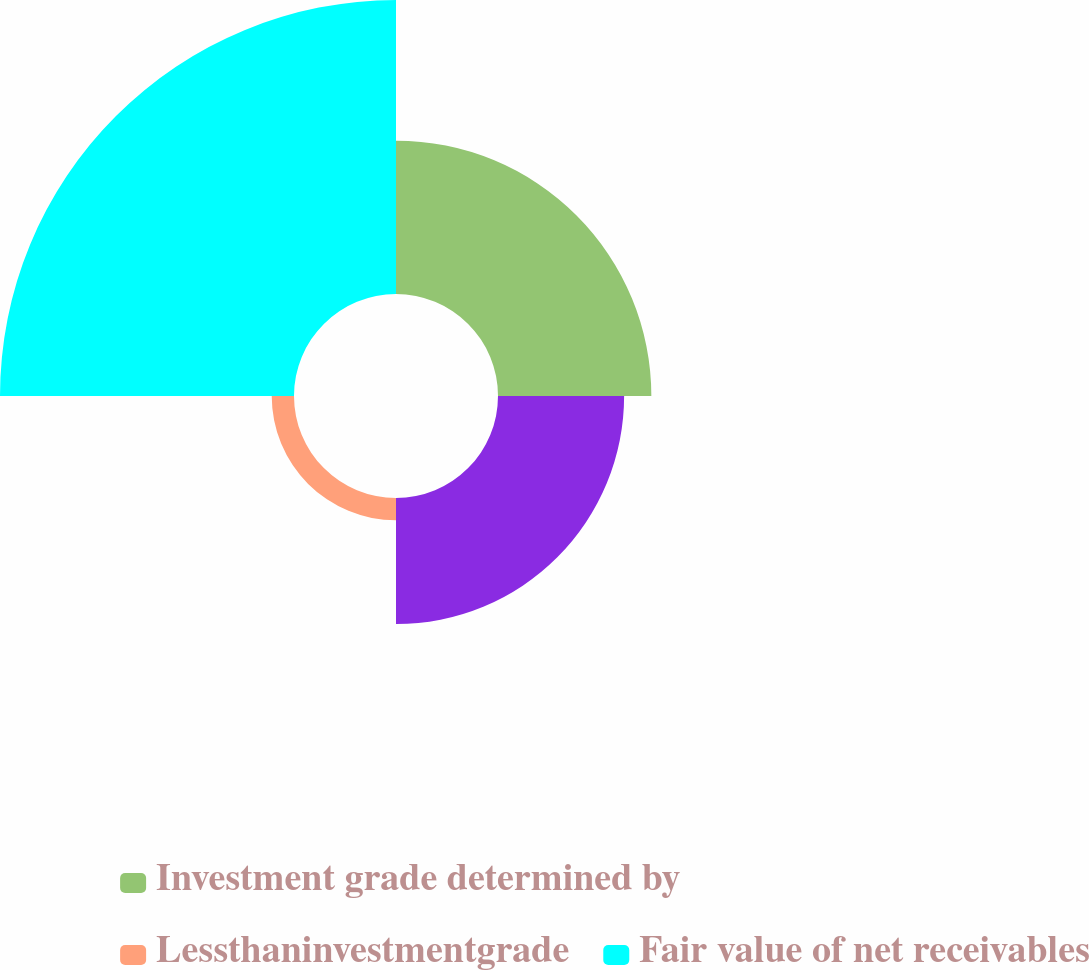<chart> <loc_0><loc_0><loc_500><loc_500><pie_chart><fcel>Investment grade determined by<fcel>Unnamed: 1<fcel>Lessthaninvestmentgrade<fcel>Fair value of net receivables<nl><fcel>25.74%<fcel>21.17%<fcel>3.74%<fcel>49.35%<nl></chart> 